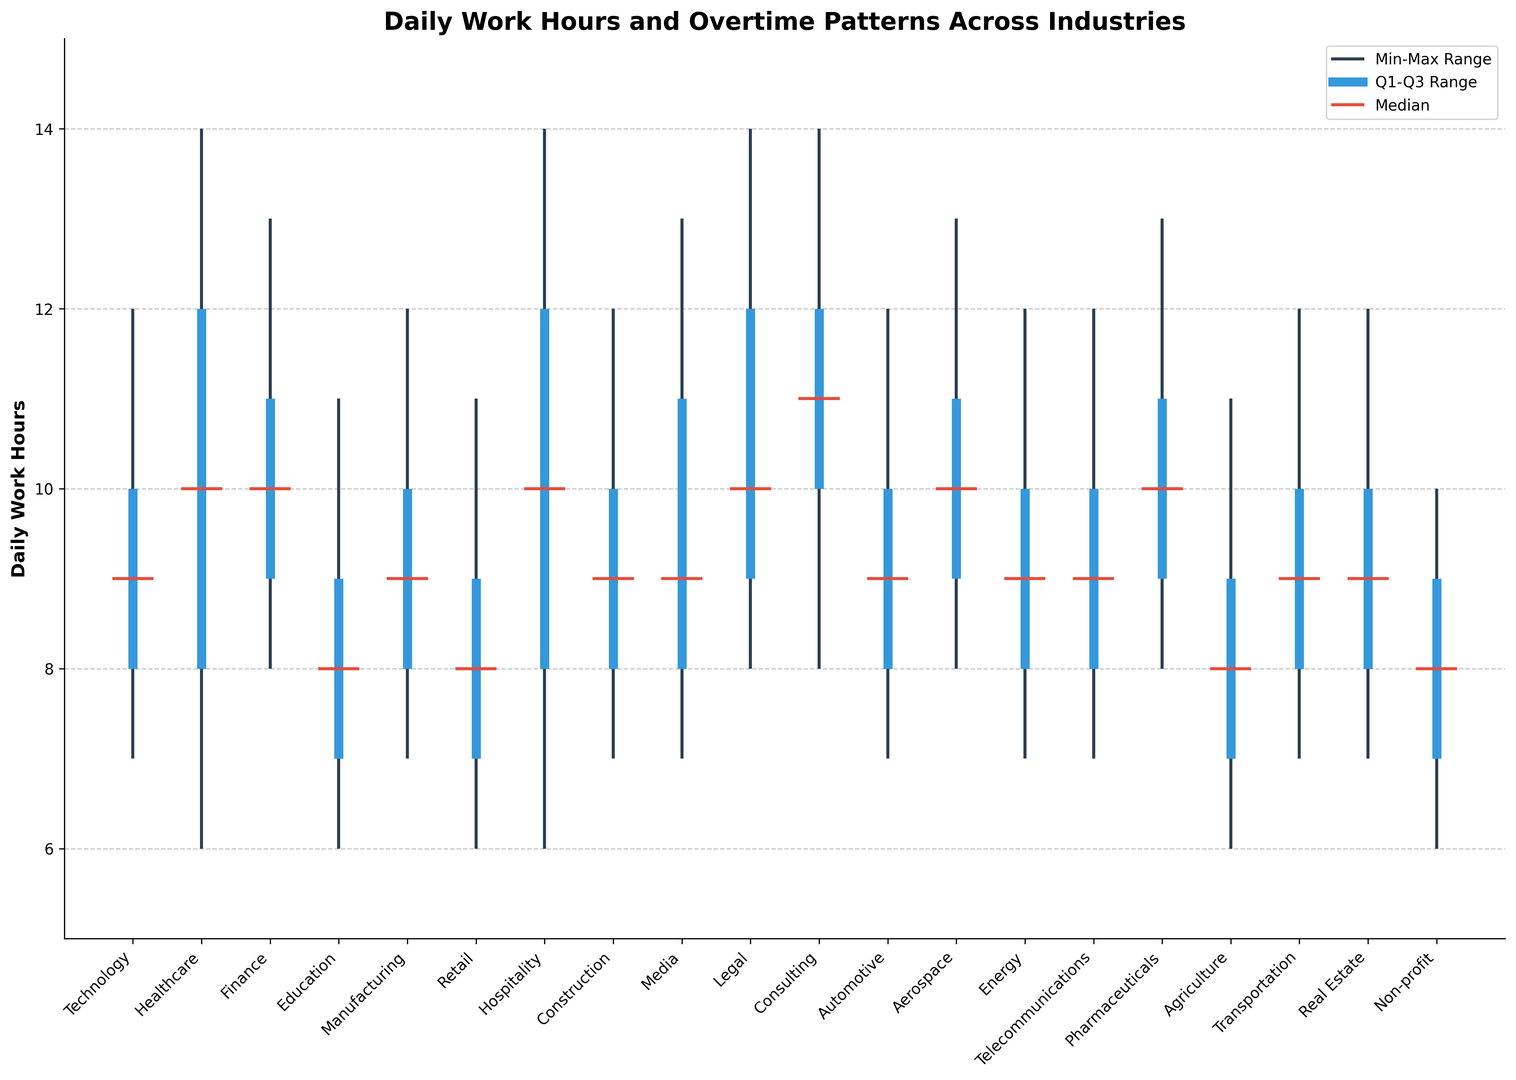Which industry has the highest median daily work hours? The plot shows the median daily work hours for each industry as red horizontal lines in the center of the bars. The industry with the red line positioned highest on the y-axis represents the highest median daily work hours.
Answer: Consulting Which industry has the widest range between minimum and maximum daily work hours? The range between minimum and maximum daily work hours is represented by vertical lines. The industry with the longest vertical line has the widest range between these values.
Answer: Healthcare and Hospitality Which industry has both the lowest minimum and maximum daily work hours? Look at the vertical lines representing the min-max range. The industry with the shortest overall min-max line, as well as the position closer to the bottom of the chart, represents the lowest minimum and maximum.
Answer: Non-profit Between Legal and Pharmaceuticals, which industry has a higher Q3 daily work hours? Q3 daily work hours are indicated by the top of the blue box section. Compare the height of the blue boxes for Legal and Pharmaceuticals and see which is positioned higher on the y-axis.
Answer: Legal What is the median daily work hours for the Automotive industry relative to the Transportation industry? Find the median daily work hour lines for both industries. Compare the positions on the y-axis to see which is higher.
Answer: They are equal What color represents the Q1-Q3 range of daily work hours? The Q1-Q3 range is indicated by the colored box section of the bar. Identify the color used for this section.
Answer: Blue What is the industry with a minimum daily work hours of 6 and a maximum of 14? Check the vertical lines that range from 6 to 14. The corresponding industry label below will be the answer.
Answer: Healthcare and Hospitality For the Finance industry, what is the difference between the maximum and minimum daily work hours? Subtract the minimum daily work hours from the maximum for Finance. Max is 13, and Min is 8, resulting in 13 - 8 = 5.
Answer: 5 Which industry has the smallest difference between Q1 and Q3 daily work hours? The Q1-Q3 range is shown within the blue box. Identify the industry with the smallest vertical height of the blue box.
Answer: Finance Comparing Technology and Retail, which industry has a larger range for Q1 to Q3 daily work hours? Identify and compare how large the blue sections are for Technology and Retail.
Answer: Technology 